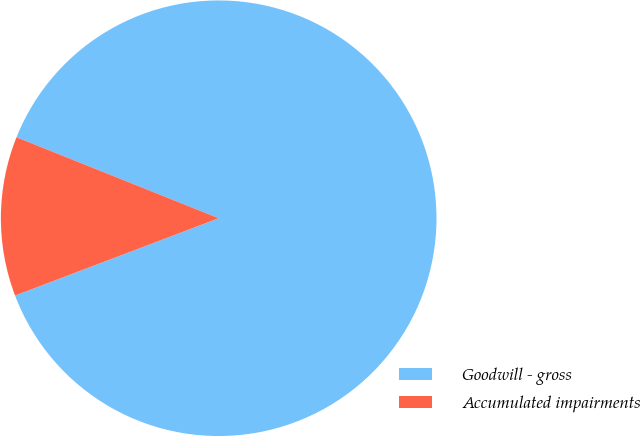<chart> <loc_0><loc_0><loc_500><loc_500><pie_chart><fcel>Goodwill - gross<fcel>Accumulated impairments<nl><fcel>88.16%<fcel>11.84%<nl></chart> 